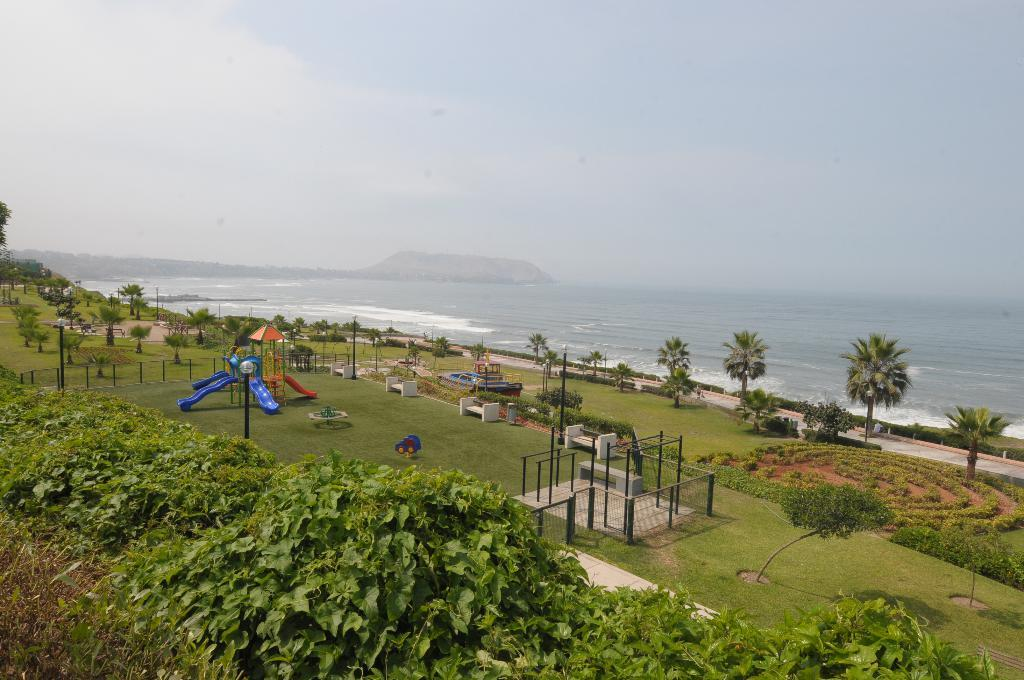What type of vegetation can be seen in the image? There are plants, trees, and grass visible in the image. What structures are present in the image? There are poles and light poles in the image. What type of seating is available in the image? There are benches in the image. What is on the ground for kids to play with? There are playing objects for kids on the ground. What can be seen in the background of the image? There are mountains, water, and clouds visible in the background of the image. How many trips can be seen on the bit of patch in the image? There is no trip or patch present in the image. What type of animal is biting the patch in the image? There is no animal or patch present in the image. 